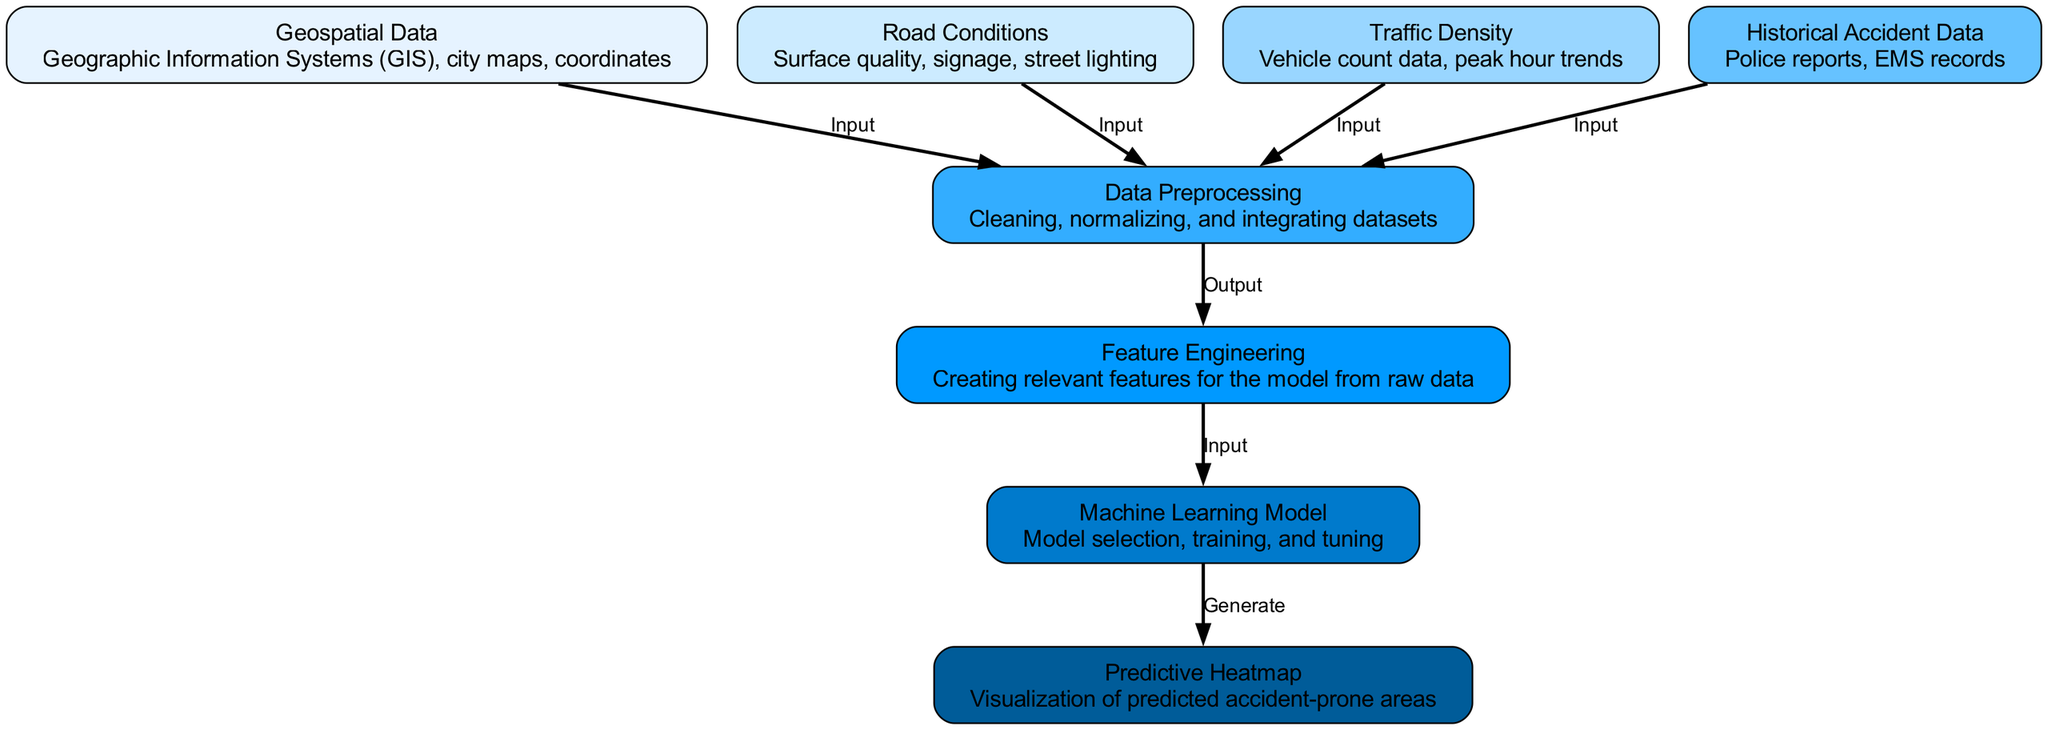What is the total number of nodes in the diagram? The diagram contains nodes representing different components of the machine learning methodology. By counting each distinct node listed under "nodes" in the data, we find there are eight nodes.
Answer: Eight How many edges connect the data preprocessing node? The data preprocessing node receives input from four nodes: geospatial data, road conditions, traffic density, and historical accident data. Thus, it is connected to these four edges.
Answer: Four What is the first step in the methodology? The first step in the methodology, as depicted in the diagram, is the collection of geospatial data, which is represented as the first input to the data preprocessing node.
Answer: Geospatial data What outcome does the machine learning model generate? According to the structure of the diagram, the machine learning model ultimately generates the predictive heatmap, which visually represents predicted accident-prone areas.
Answer: Predictive heatmap How do road conditions contribute to the process? Road conditions serve as one of the inputs to the data preprocessing node, contributing data about surface quality, signage, and street lighting, which are essential for the analysis.
Answer: Input What is the relationship between feature engineering and the machine learning model? Feature engineering acts as a preparatory step that supplies relevant features to the machine learning model, establishing a direct input-output connection between these two nodes.
Answer: Input Which data source is crucial for training the machine learning model? Historical accident data is essential for training the machine learning model, as it provides insights from past incidents that inform predictions and feature selections.
Answer: Historical accident data What is the primary goal of generating a predictive heatmap? The primary goal of generating a predictive heatmap is to visualize areas in the city that are predicted to be accident-prone based on the integrated analysis of the input data.
Answer: Visualization of predicted accident-prone areas 